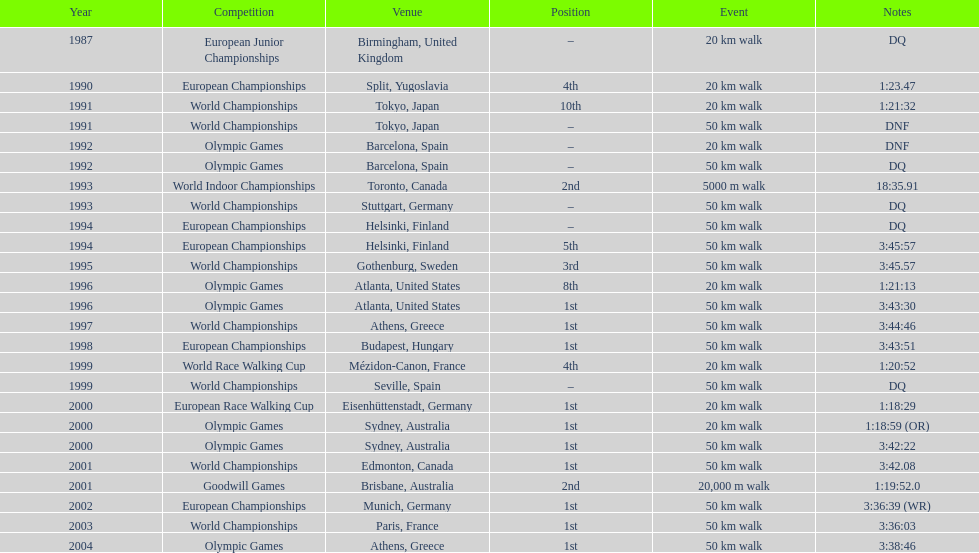How many incidents happened at a minimum of 50 km? 17. 